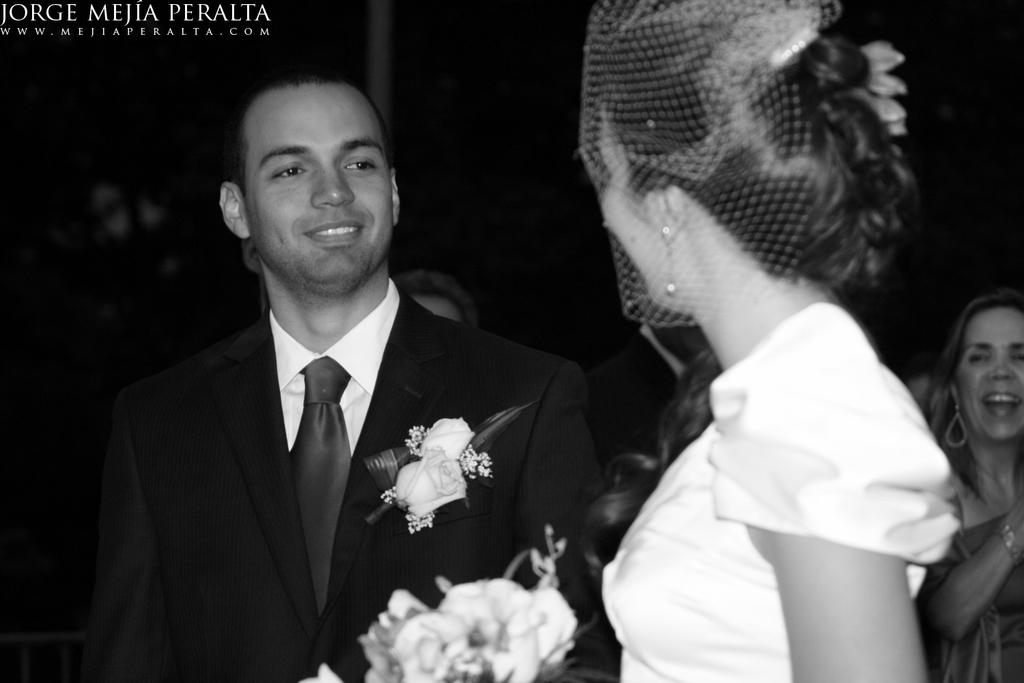Who are the two main subjects in the image? There is a man (groom) and a woman (bride) in the image. What might the woman be holding in the image? There is a flower bouquet in the image, which the woman (bride) might be holding. Can you describe the background of the image? There are people in the background of the image. Is there any text or logo visible in the image? Yes, a watermark is visible in the top left corner of the image. What color is the paint splattered on the groom's suit in the image? There is no paint splattered on the groom's suit in the image; it is a wedding scene with a groom and bride. What trick is the bride performing in the image? There is no trick being performed in the image; it is a standard wedding portrait with the bride and groom. 